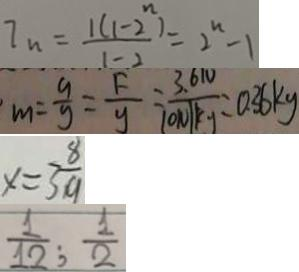<formula> <loc_0><loc_0><loc_500><loc_500>I _ { n } = \frac { 1 ( 1 - 2 ^ { n } ) } { 1 - 2 } = 2 ^ { n } - 1 
 m = \frac { 9 } { y } = \frac { F } { y } = \frac { 3 . 6 N } { 1 0 N / k g } = 0 . 3 6 k g 
 x = 3 \frac { 8 } { 9 } 
 \frac { 1 } { 1 2 } ; \frac { 1 } { 2 }</formula> 